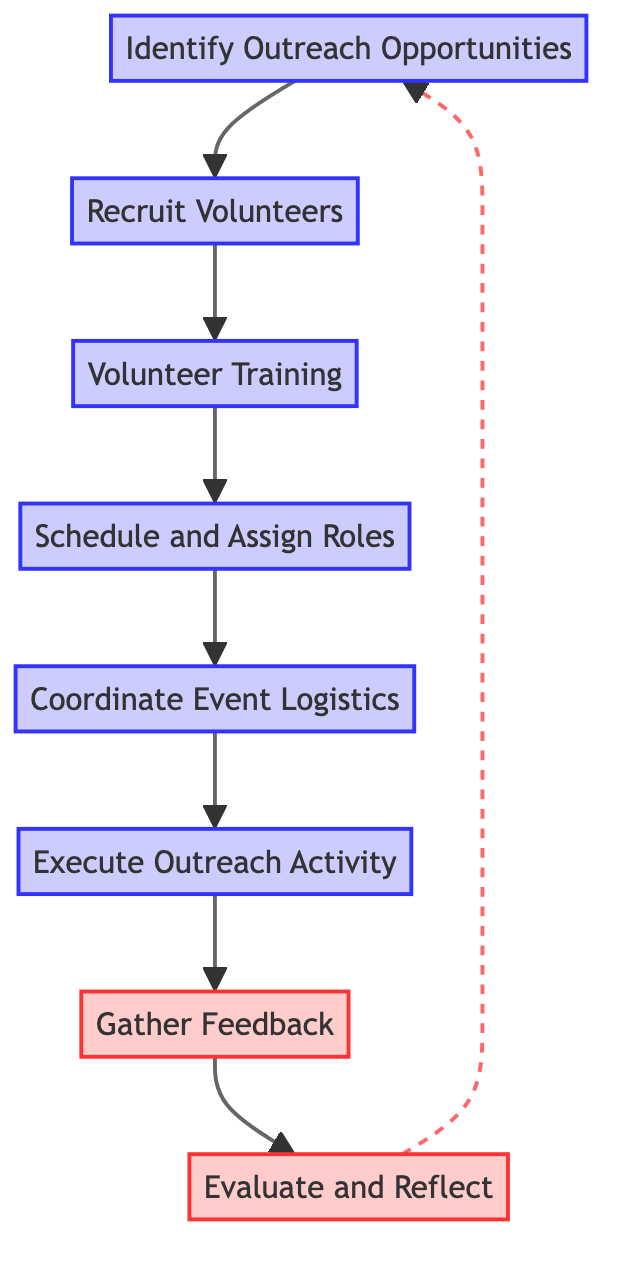What is the first step in the volunteer coordination process? The first step in the diagram is labeled "Identify Outreach Opportunities". It is the starting point from which all other steps follow.
Answer: Identify Outreach Opportunities How many total nodes are present in the flow chart? The flow chart contains eight distinct nodes that represent different steps in the volunteer coordination process.
Answer: Eight What follows "Recruit Volunteers" in the process? The node that follows "Recruit Volunteers" is "Volunteer Training", indicating that after recruiting volunteers, the next step is to provide training.
Answer: Volunteer Training Which step involves collecting opinions about the outreach activities? The step that involves collecting opinions is labeled "Gather Feedback". It is focused on obtaining input from volunteers and community members regarding the activities.
Answer: Gather Feedback What is the last step before going back to identify new opportunities? The last step before returning to "Identify Outreach Opportunities" is "Evaluate and Reflect". This indicates a review and discussion phase after gathering feedback.
Answer: Evaluate and Reflect Which step includes organizing materials and support? The step that includes organizing materials and support is known as "Coordinate Event Logistics". This is where logistical aspects are addressed before executing the outreach activity.
Answer: Coordinate Event Logistics What type of arrows are used to connect "Gather Feedback" to "Evaluate and Reflect"? The connection from "Gather Feedback" to "Evaluate and Reflect" uses a dashed line, indicating that this relationship might represent a feedback loop rather than a direct progression.
Answer: Dashed line What is the purpose of the "Volunteer Training" step? The purpose of "Volunteer Training" is to provide necessary training and guidelines for volunteers, ensuring they are prepared and informed for the outreach activities.
Answer: Provide necessary training and guidelines 